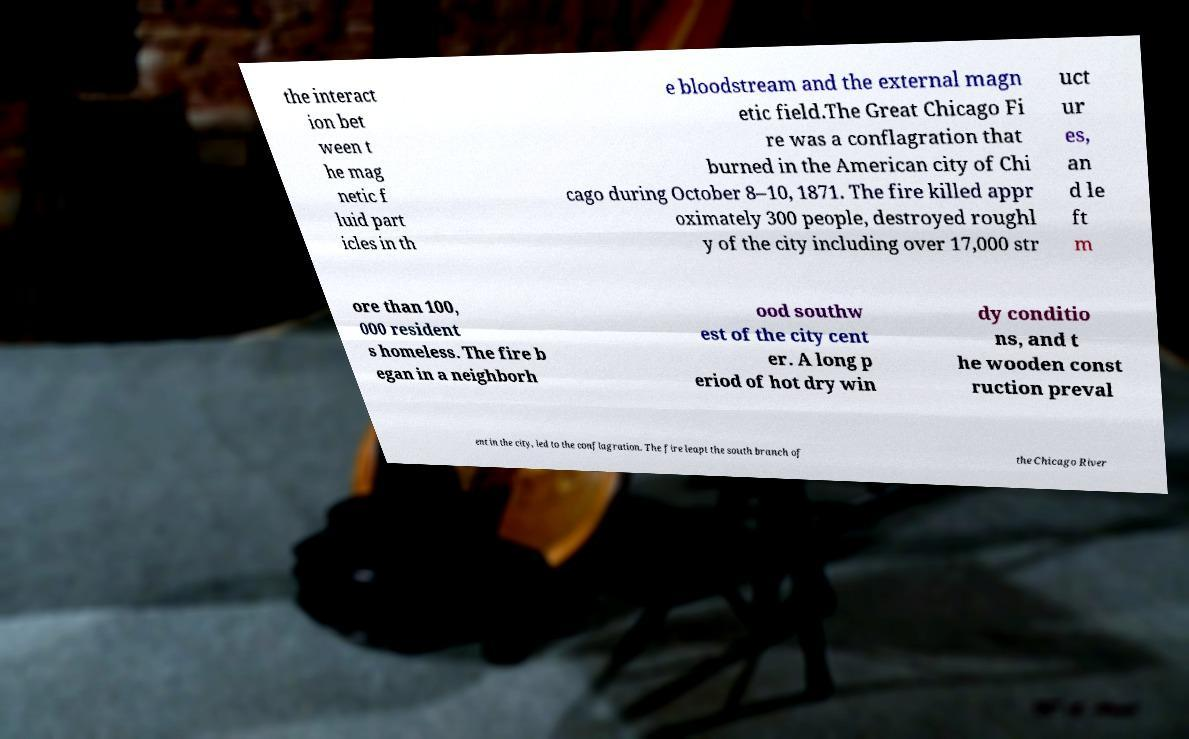For documentation purposes, I need the text within this image transcribed. Could you provide that? the interact ion bet ween t he mag netic f luid part icles in th e bloodstream and the external magn etic field.The Great Chicago Fi re was a conflagration that burned in the American city of Chi cago during October 8–10, 1871. The fire killed appr oximately 300 people, destroyed roughl y of the city including over 17,000 str uct ur es, an d le ft m ore than 100, 000 resident s homeless. The fire b egan in a neighborh ood southw est of the city cent er. A long p eriod of hot dry win dy conditio ns, and t he wooden const ruction preval ent in the city, led to the conflagration. The fire leapt the south branch of the Chicago River 